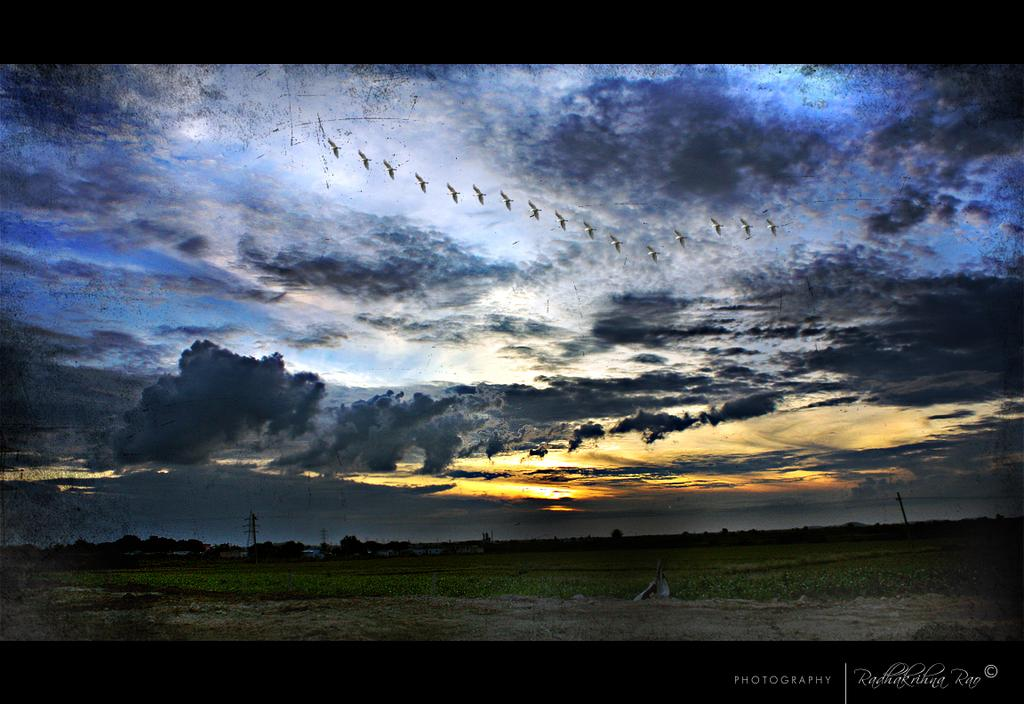What is the main subject of the image? The main subject of the image is a crop. What can be seen in the sky in the image? There are clouds in the sky in the image. Are there any unusual elements in the sky? Yes, there are boats in the sky in the image. Is there any text present in the image? Yes, there is a text in the bottom right of the image. Can you see a person holding a yak's finger in the image? There is no person or yak present in the image, and therefore no such interaction can be observed. 